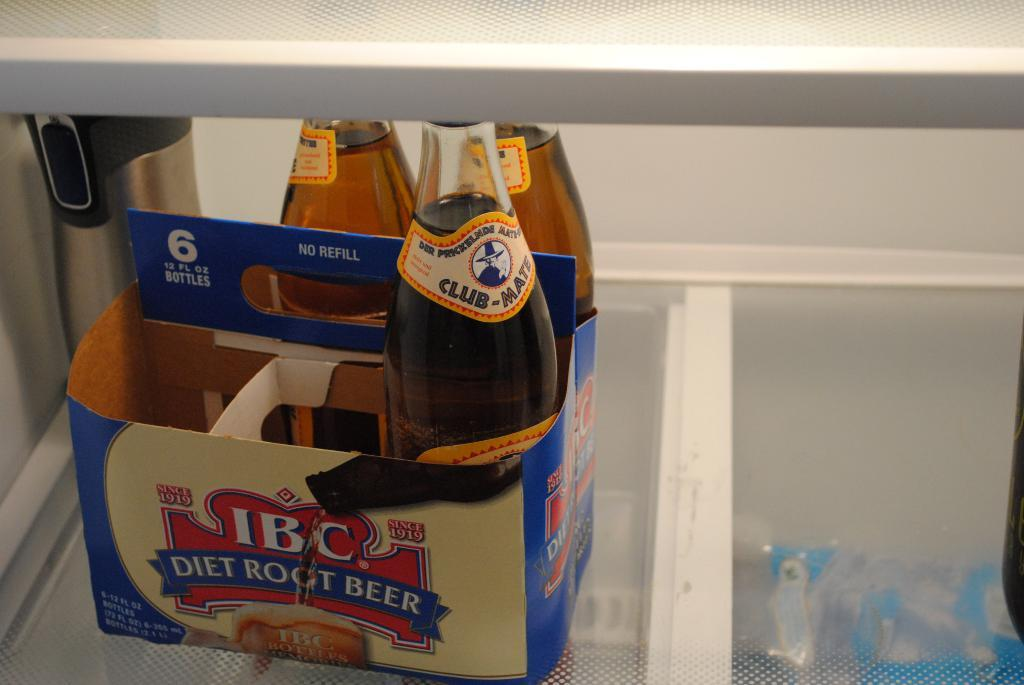<image>
Give a short and clear explanation of the subsequent image. Box full of beer with a label that says Diet Root Beer on it. 